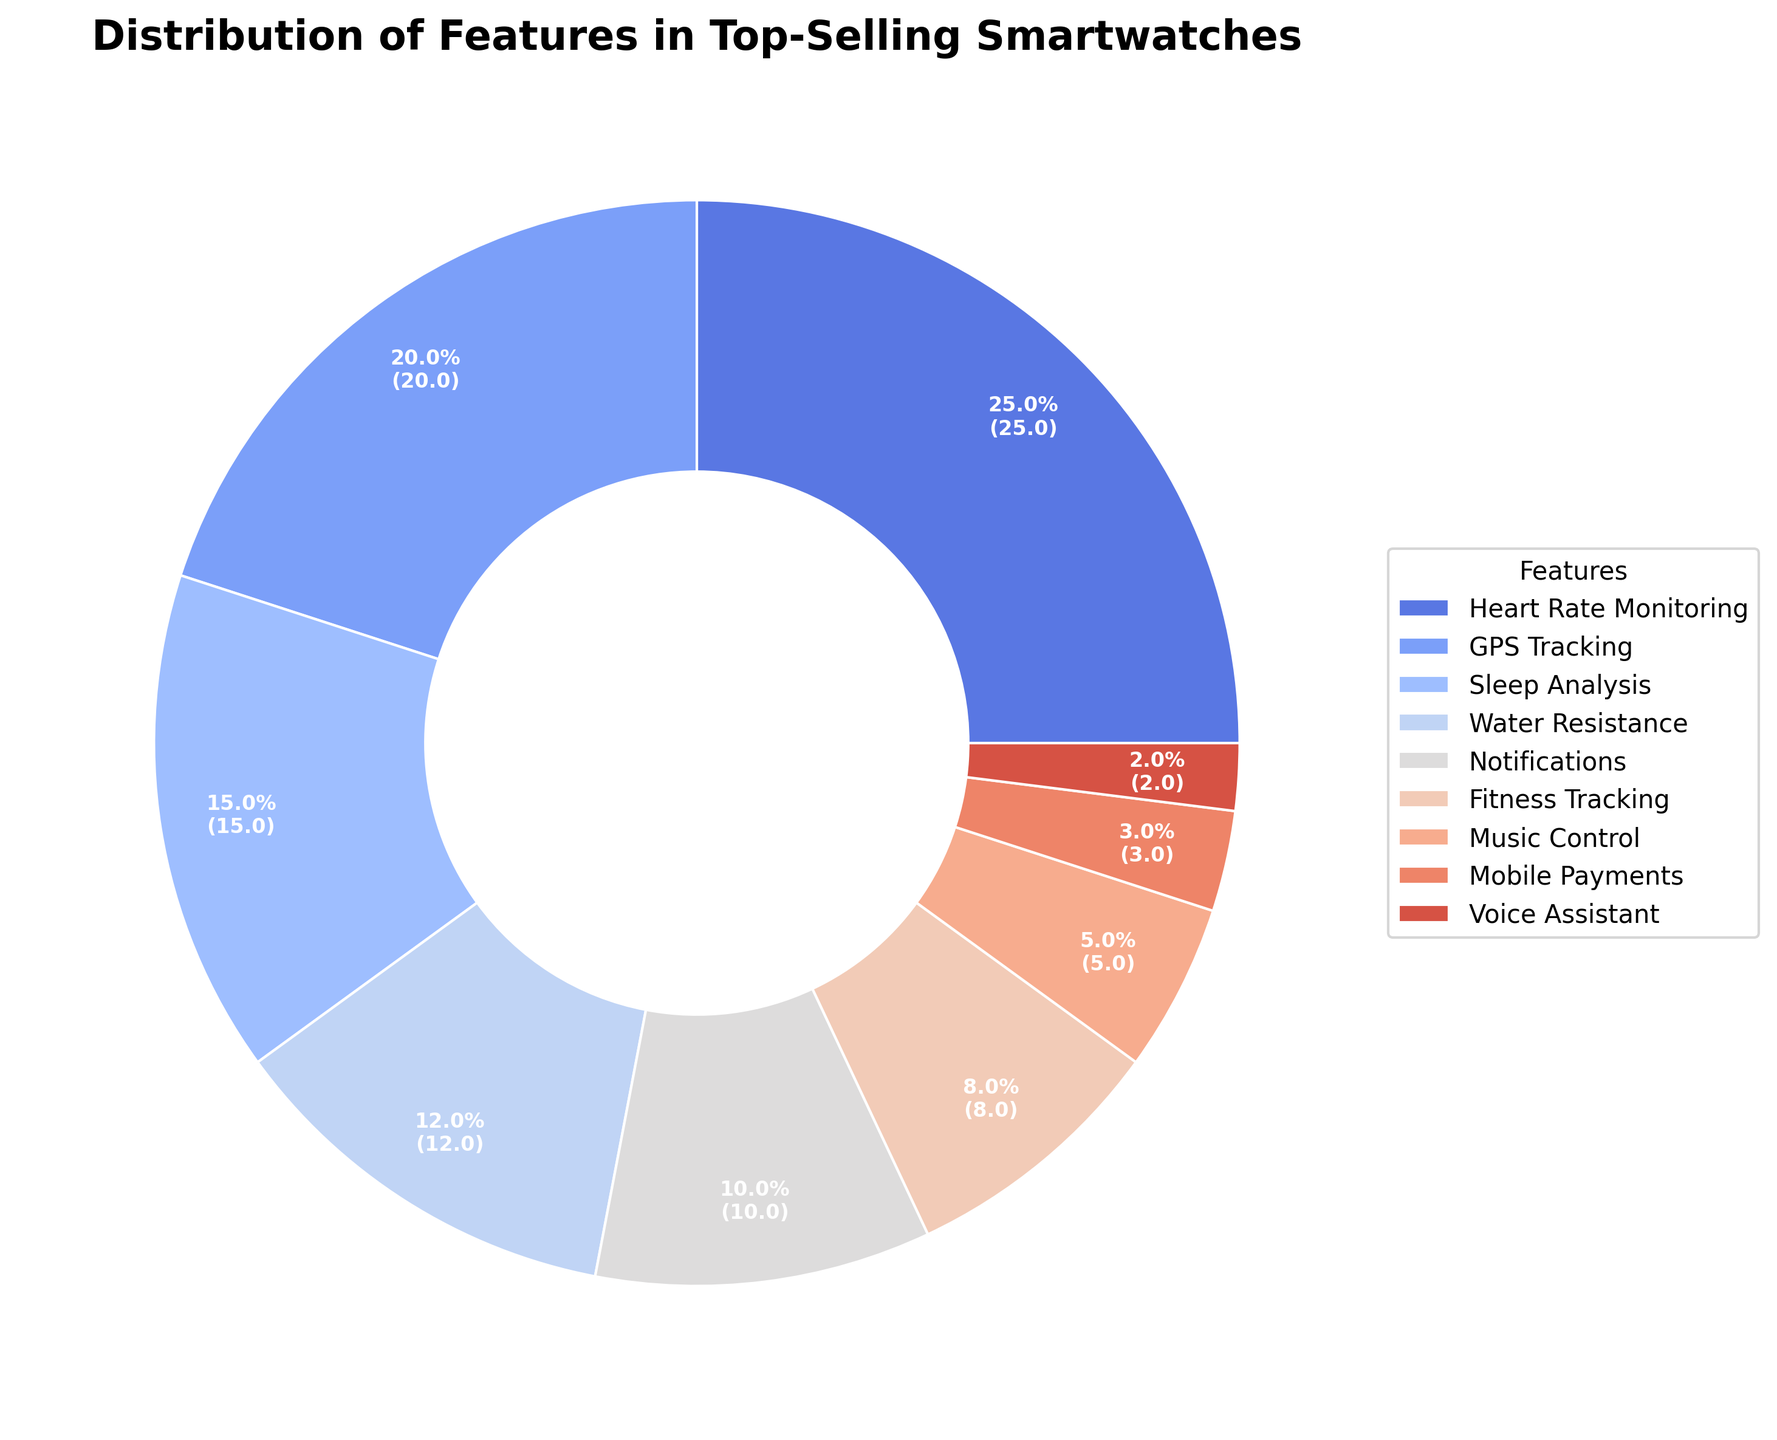What feature has the highest percentage in top-selling smartwatches? From the pie chart, Heart Rate Monitoring has the largest slice, representing the highest percentage among the features.
Answer: Heart Rate Monitoring Which two features combined make up the largest portion of the features distribution? Heart Rate Monitoring and GPS Tracking are the two largest slices in the pie chart. Adding their percentages: 25% + 20% = 45%.
Answer: Heart Rate Monitoring and GPS Tracking How does the percentage of Sleep Analysis compare to that of Water Resistance? From the pie chart, Sleep Analysis has a percentage of 15%, while Water Resistance has 12%. Sleep Analysis is 3% higher than Water Resistance.
Answer: Sleep Analysis is higher by 3% What is the combined percentage of Music Control, Mobile Payments, and Voice Assistant? Adding the percentages of Music Control (5%), Mobile Payments (3%), and Voice Assistant (2%): 5% + 3% + 2% = 10%.
Answer: 10% Which feature has the smallest percentage, and what is it? The smallest slice in the pie chart represents Voice Assistant, at 2%.
Answer: Voice Assistant, 2% Is the percentage of Heart Rate Monitoring greater than the sum of Mobile Payments and Voice Assistant? Heart Rate Monitoring is 25%. The sum of Mobile Payments and Voice Assistant is 3% + 2% = 5%. Since 25% > 5%, Heart Rate Monitoring is indeed greater.
Answer: Yes What is the difference in percentage between Notifications and Fitness Tracking? Notifications are at 10%, and Fitness Tracking is at 8%. The difference is 10% - 8% = 2%.
Answer: 2% Which feature shown in blue is represented in the chart? Sleep Analysis is often represented in blue in such charts and constitutes 15% of the distribution.
Answer: Sleep Analysis Calculate the average percentage of the top four features. The top four features are Heart Rate Monitoring (25%), GPS Tracking (20%), Sleep Analysis (15%), and Water Resistance (12%). The average is (25% + 20% + 15% + 12%) / 4 = 72% / 4 = 18%.
Answer: 18% If the percentages of GPS Tracking and Notifications are combined, how does it compare to the percentage of Heart Rate Monitoring? GPS Tracking and Notifications combined are 20% + 10% = 30%. Heart Rate Monitoring is 25%. Thus, 30% > 25%.
Answer: Greater by 5% 